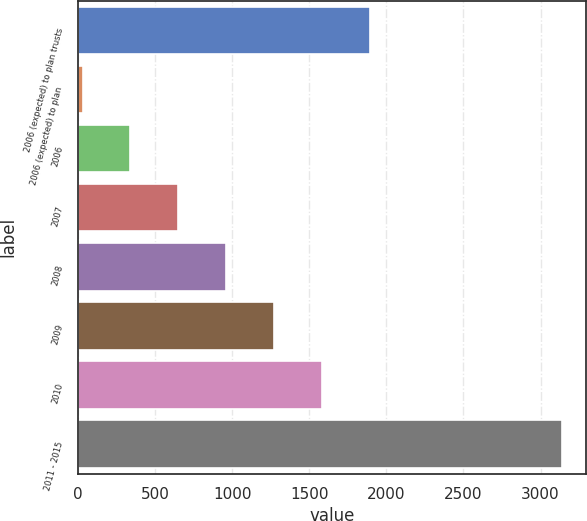Convert chart. <chart><loc_0><loc_0><loc_500><loc_500><bar_chart><fcel>2006 (expected) to plan trusts<fcel>2006 (expected) to plan<fcel>2006<fcel>2007<fcel>2008<fcel>2009<fcel>2010<fcel>2011 - 2015<nl><fcel>1893.6<fcel>30<fcel>340.6<fcel>651.2<fcel>961.8<fcel>1272.4<fcel>1583<fcel>3136<nl></chart> 